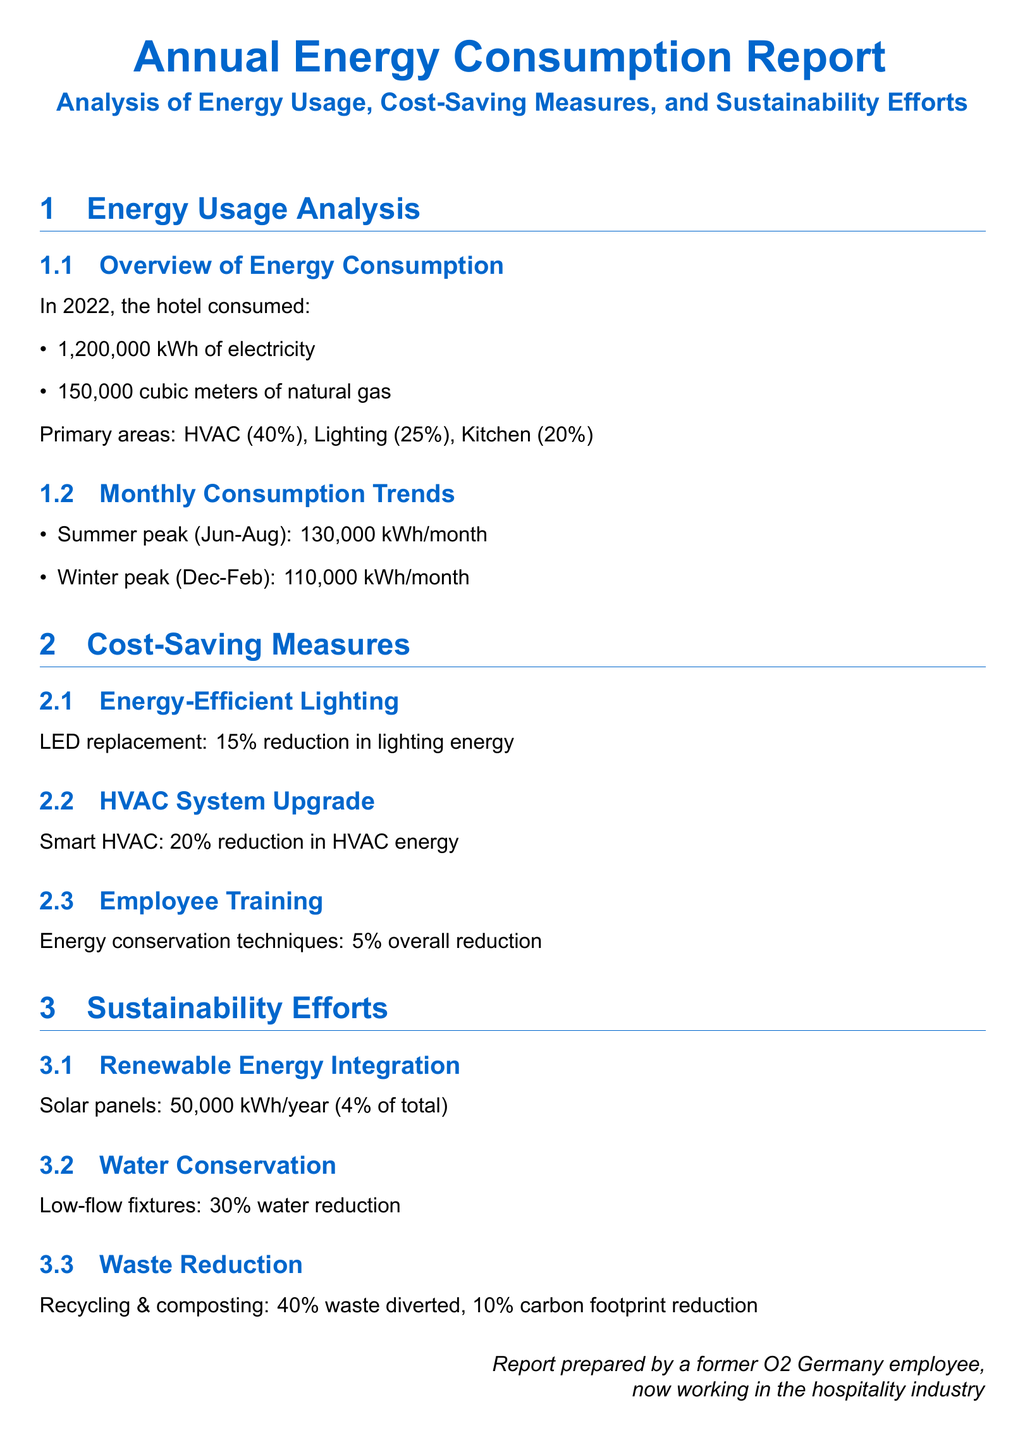What was the total electricity consumption in 2022? The total electricity consumption is specifically stated in the document as 1,200,000 kWh.
Answer: 1,200,000 kWh What percentage of energy consumption is attributed to HVAC? The document specifies that HVAC accounts for 40% of the total energy consumption.
Answer: 40% How much natural gas did the hotel consume in cubic meters? The document provides the natural gas consumption as 150,000 cubic meters.
Answer: 150,000 cubic meters What was the reduction in lighting energy due to LED replacement? The document states there was a 15% reduction in lighting energy due to the LED replacement.
Answer: 15% What is the total reduction in energy consumption attributed to employee training? The document indicates that employee training led to a 5% overall reduction in energy consumption.
Answer: 5% What is the renewable energy contribution from solar panels? The contribution from solar panels is noted as 50,000 kWh/year which is 4% of the total energy consumption.
Answer: 50,000 kWh/year How much water was reduced through low-flow fixtures? The document mentions a 30% reduction in water usage due to low-flow fixtures.
Answer: 30% What percentage of waste was diverted through recycling and composting? According to the document, 40% of waste was diverted through recycling and composting efforts.
Answer: 40% What is the primary area with the highest energy consumption? The highest energy consumption area mentioned in the document is HVAC at 40%.
Answer: HVAC 